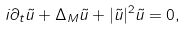<formula> <loc_0><loc_0><loc_500><loc_500>i \partial _ { t } \tilde { u } + \Delta _ { M } \tilde { u } + | \tilde { u } | ^ { 2 } \tilde { u } = 0 ,</formula> 